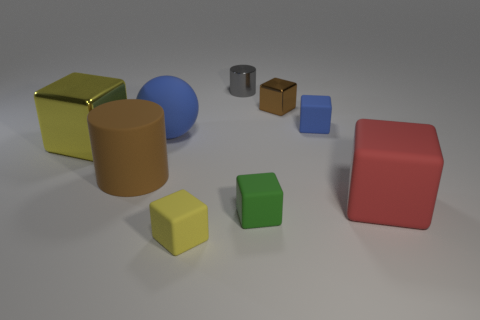Subtract all brown blocks. How many blocks are left? 5 Subtract all large cubes. How many cubes are left? 4 Subtract 2 cubes. How many cubes are left? 4 Subtract all purple cubes. Subtract all brown balls. How many cubes are left? 6 Add 1 big brown rubber things. How many objects exist? 10 Subtract all blocks. How many objects are left? 3 Add 1 tiny green rubber blocks. How many tiny green rubber blocks are left? 2 Add 9 large brown rubber cylinders. How many large brown rubber cylinders exist? 10 Subtract 0 cyan blocks. How many objects are left? 9 Subtract all large blue cylinders. Subtract all rubber cylinders. How many objects are left? 8 